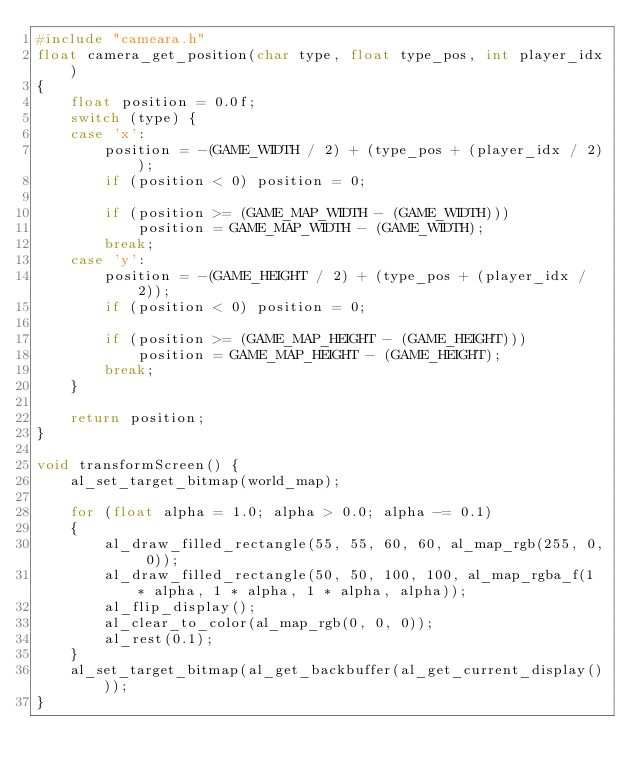Convert code to text. <code><loc_0><loc_0><loc_500><loc_500><_C_>#include "cameara.h"
float camera_get_position(char type, float type_pos, int player_idx)
{
	float position = 0.0f;
	switch (type) {
	case 'x':
		position = -(GAME_WIDTH / 2) + (type_pos + (player_idx / 2));
		if (position < 0) position = 0;

		if (position >= (GAME_MAP_WIDTH - (GAME_WIDTH)))
			position = GAME_MAP_WIDTH - (GAME_WIDTH);
		break;
	case 'y':
		position = -(GAME_HEIGHT / 2) + (type_pos + (player_idx / 2));
		if (position < 0) position = 0;

		if (position >= (GAME_MAP_HEIGHT - (GAME_HEIGHT)))
			position = GAME_MAP_HEIGHT - (GAME_HEIGHT);
		break;
	}

	return position;
}

void transformScreen() {
	al_set_target_bitmap(world_map);

	for (float alpha = 1.0; alpha > 0.0; alpha -= 0.1)
	{
		al_draw_filled_rectangle(55, 55, 60, 60, al_map_rgb(255, 0, 0));
		al_draw_filled_rectangle(50, 50, 100, 100, al_map_rgba_f(1 * alpha, 1 * alpha, 1 * alpha, alpha));
		al_flip_display();
		al_clear_to_color(al_map_rgb(0, 0, 0));
		al_rest(0.1);
	}
	al_set_target_bitmap(al_get_backbuffer(al_get_current_display()));
}</code> 